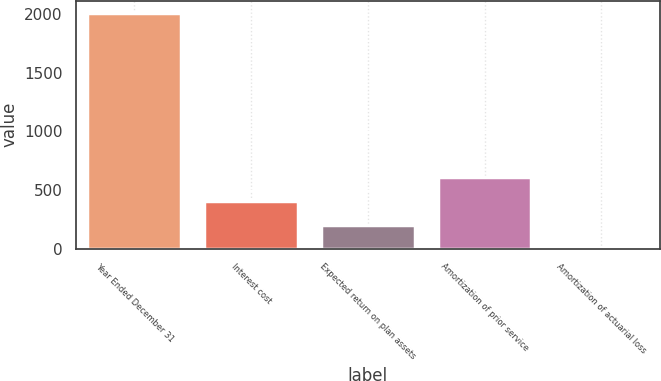Convert chart. <chart><loc_0><loc_0><loc_500><loc_500><bar_chart><fcel>Year Ended December 31<fcel>Interest cost<fcel>Expected return on plan assets<fcel>Amortization of prior service<fcel>Amortization of actuarial loss<nl><fcel>2012<fcel>407.2<fcel>206.6<fcel>607.8<fcel>6<nl></chart> 